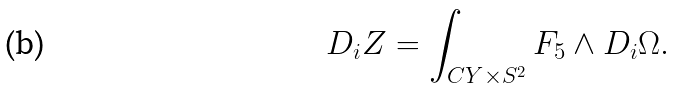<formula> <loc_0><loc_0><loc_500><loc_500>D _ { i } Z = \int _ { C Y \times S ^ { 2 } } F _ { 5 } \wedge D _ { i } \Omega .</formula> 